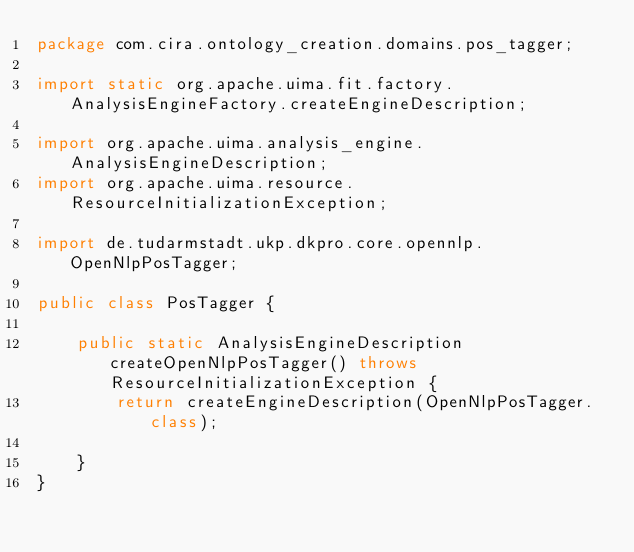<code> <loc_0><loc_0><loc_500><loc_500><_Java_>package com.cira.ontology_creation.domains.pos_tagger;

import static org.apache.uima.fit.factory.AnalysisEngineFactory.createEngineDescription;

import org.apache.uima.analysis_engine.AnalysisEngineDescription;
import org.apache.uima.resource.ResourceInitializationException;

import de.tudarmstadt.ukp.dkpro.core.opennlp.OpenNlpPosTagger;

public class PosTagger {

    public static AnalysisEngineDescription createOpenNlpPosTagger() throws ResourceInitializationException {
        return createEngineDescription(OpenNlpPosTagger.class);

    }
}
</code> 